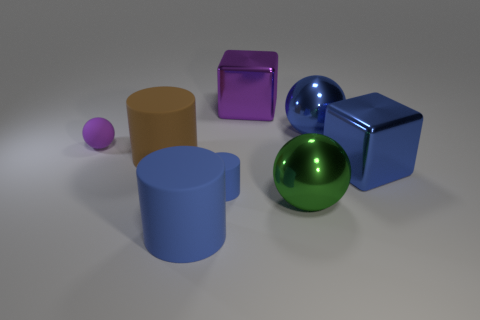What is the shape of the large blue object that is made of the same material as the blue ball?
Offer a very short reply. Cube. Does the big blue matte object have the same shape as the small thing that is right of the small purple object?
Your answer should be very brief. Yes. The purple object that is to the right of the big rubber object on the right side of the brown matte thing is made of what material?
Your answer should be compact. Metal. How many other objects are the same shape as the large purple object?
Your answer should be compact. 1. Is the shape of the small matte object on the left side of the small blue matte cylinder the same as the big metallic thing that is in front of the small blue rubber object?
Ensure brevity in your answer.  Yes. Are there any other things that have the same material as the tiny ball?
Provide a short and direct response. Yes. What is the blue sphere made of?
Keep it short and to the point. Metal. There is a large blue cylinder that is in front of the tiny purple matte object; what is its material?
Ensure brevity in your answer.  Rubber. Is there anything else that is the same color as the rubber ball?
Provide a short and direct response. Yes. The sphere that is the same material as the small blue object is what size?
Make the answer very short. Small. 